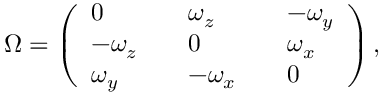Convert formula to latex. <formula><loc_0><loc_0><loc_500><loc_500>\Omega = \left ( \begin{array} { l l l l l } { 0 } & { \omega _ { z } } & { - \omega _ { y } } \\ { - \omega _ { z } } & { 0 } & { \omega _ { x } } \\ { \omega _ { y } } & { - \omega _ { x } } & { 0 } \end{array} \right ) ,</formula> 